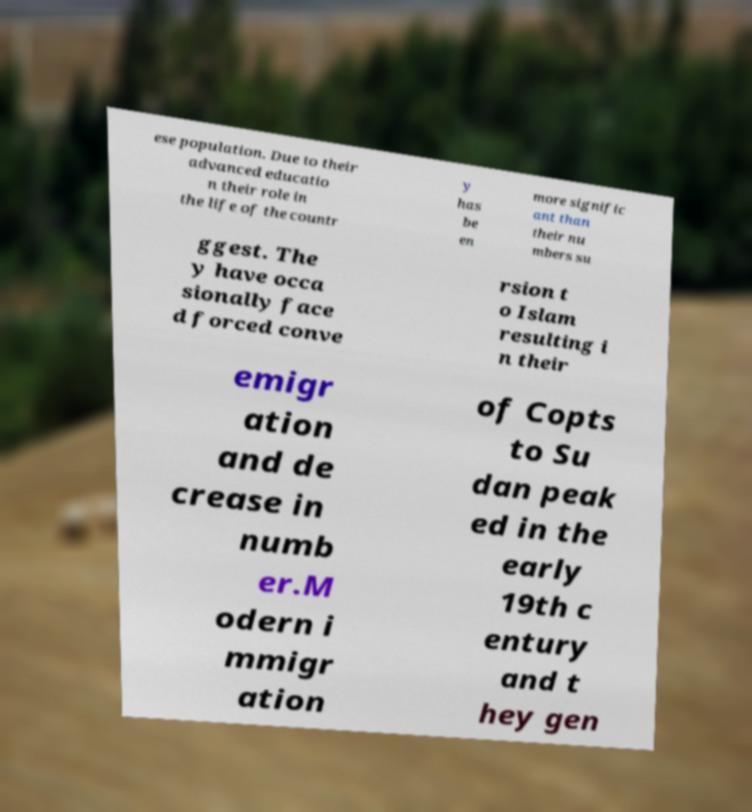What messages or text are displayed in this image? I need them in a readable, typed format. ese population. Due to their advanced educatio n their role in the life of the countr y has be en more signific ant than their nu mbers su ggest. The y have occa sionally face d forced conve rsion t o Islam resulting i n their emigr ation and de crease in numb er.M odern i mmigr ation of Copts to Su dan peak ed in the early 19th c entury and t hey gen 